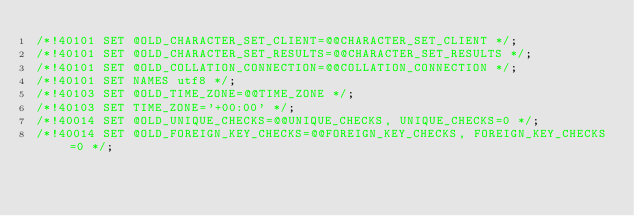Convert code to text. <code><loc_0><loc_0><loc_500><loc_500><_SQL_>/*!40101 SET @OLD_CHARACTER_SET_CLIENT=@@CHARACTER_SET_CLIENT */;
/*!40101 SET @OLD_CHARACTER_SET_RESULTS=@@CHARACTER_SET_RESULTS */;
/*!40101 SET @OLD_COLLATION_CONNECTION=@@COLLATION_CONNECTION */;
/*!40101 SET NAMES utf8 */;
/*!40103 SET @OLD_TIME_ZONE=@@TIME_ZONE */;
/*!40103 SET TIME_ZONE='+00:00' */;
/*!40014 SET @OLD_UNIQUE_CHECKS=@@UNIQUE_CHECKS, UNIQUE_CHECKS=0 */;
/*!40014 SET @OLD_FOREIGN_KEY_CHECKS=@@FOREIGN_KEY_CHECKS, FOREIGN_KEY_CHECKS=0 */;</code> 